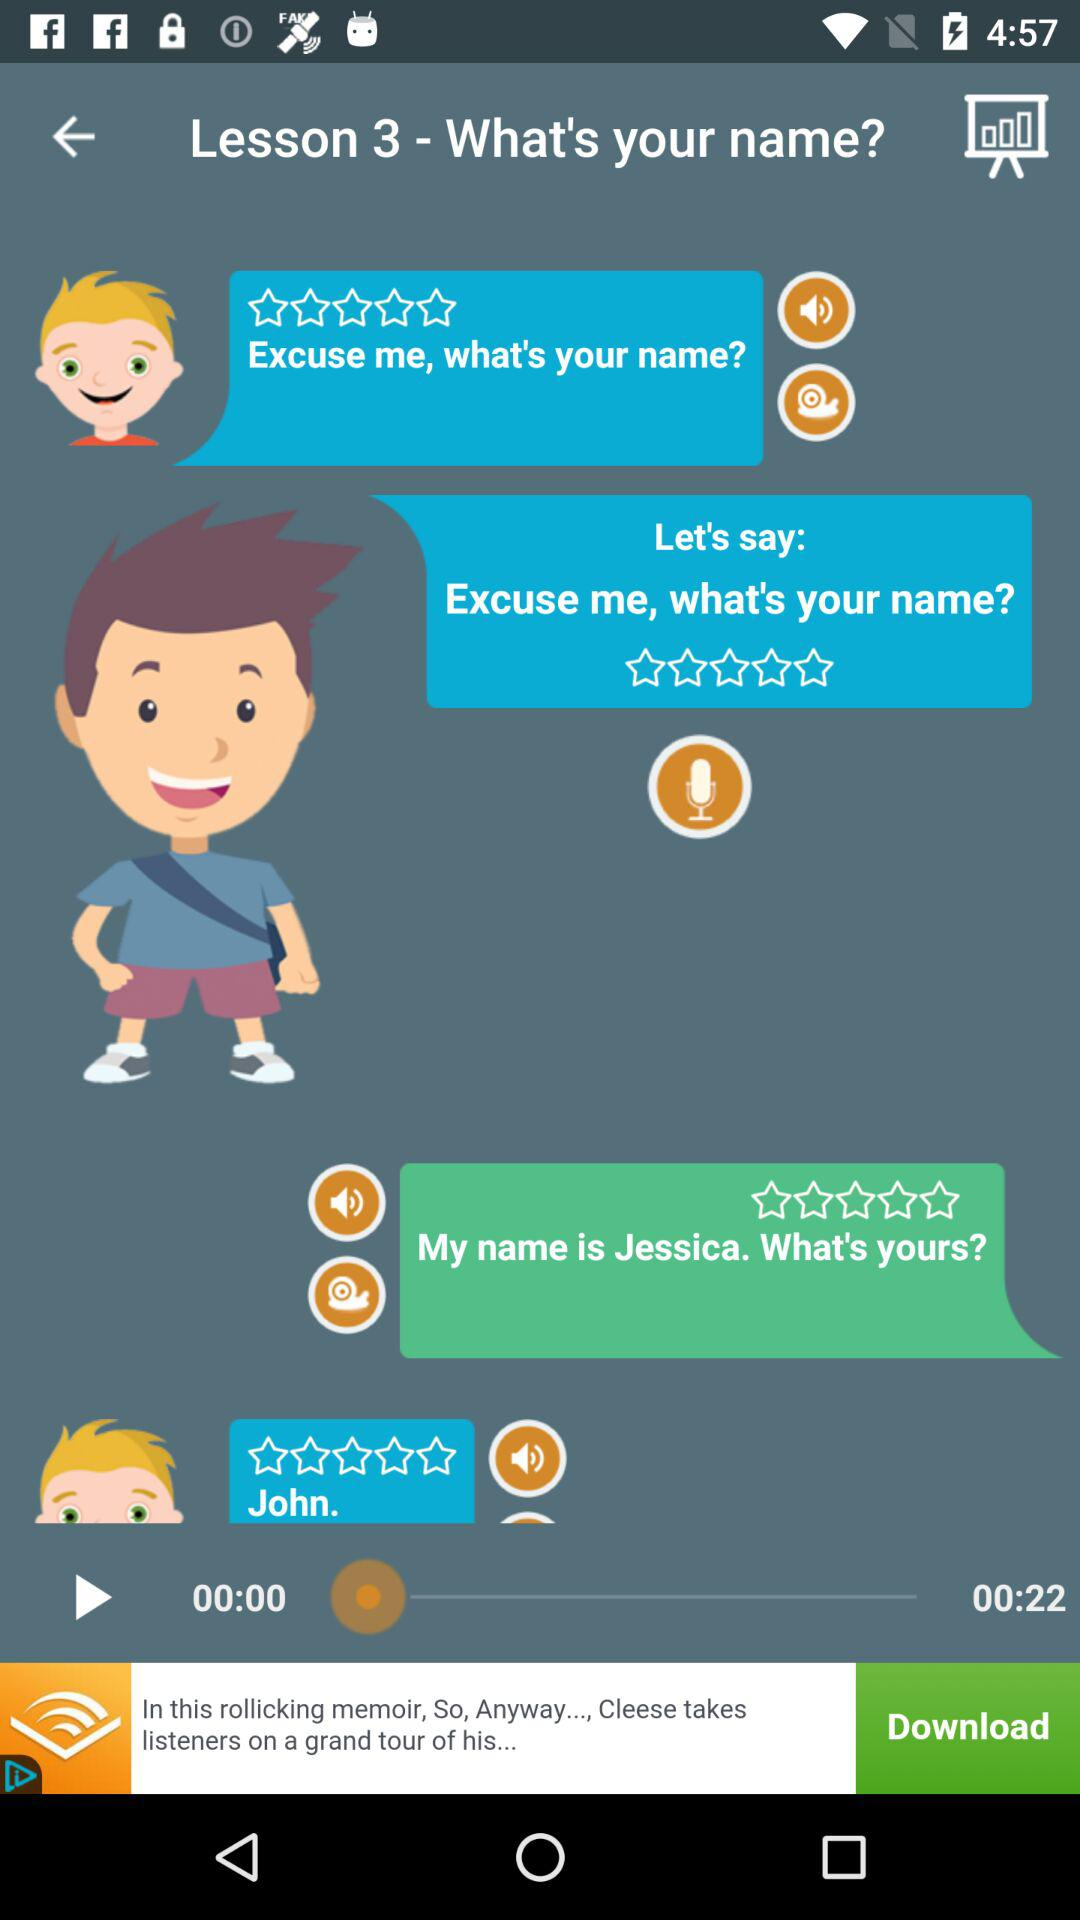What is lesson 3? Lesson 3 is "What's your name?". 